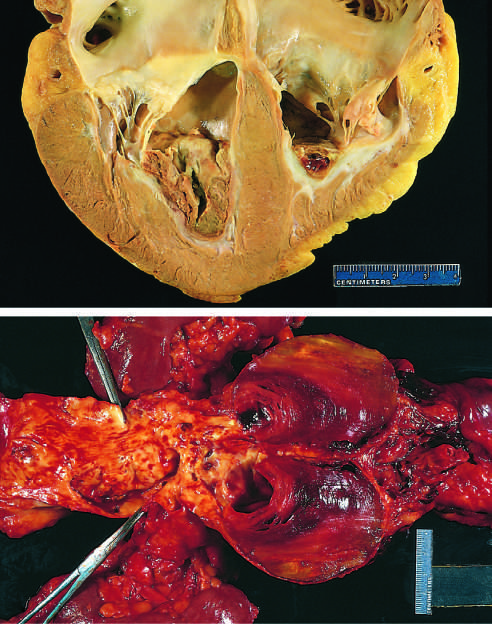did the areas of white chalky deposits overlie white fibrous scar?
Answer the question using a single word or phrase. No 